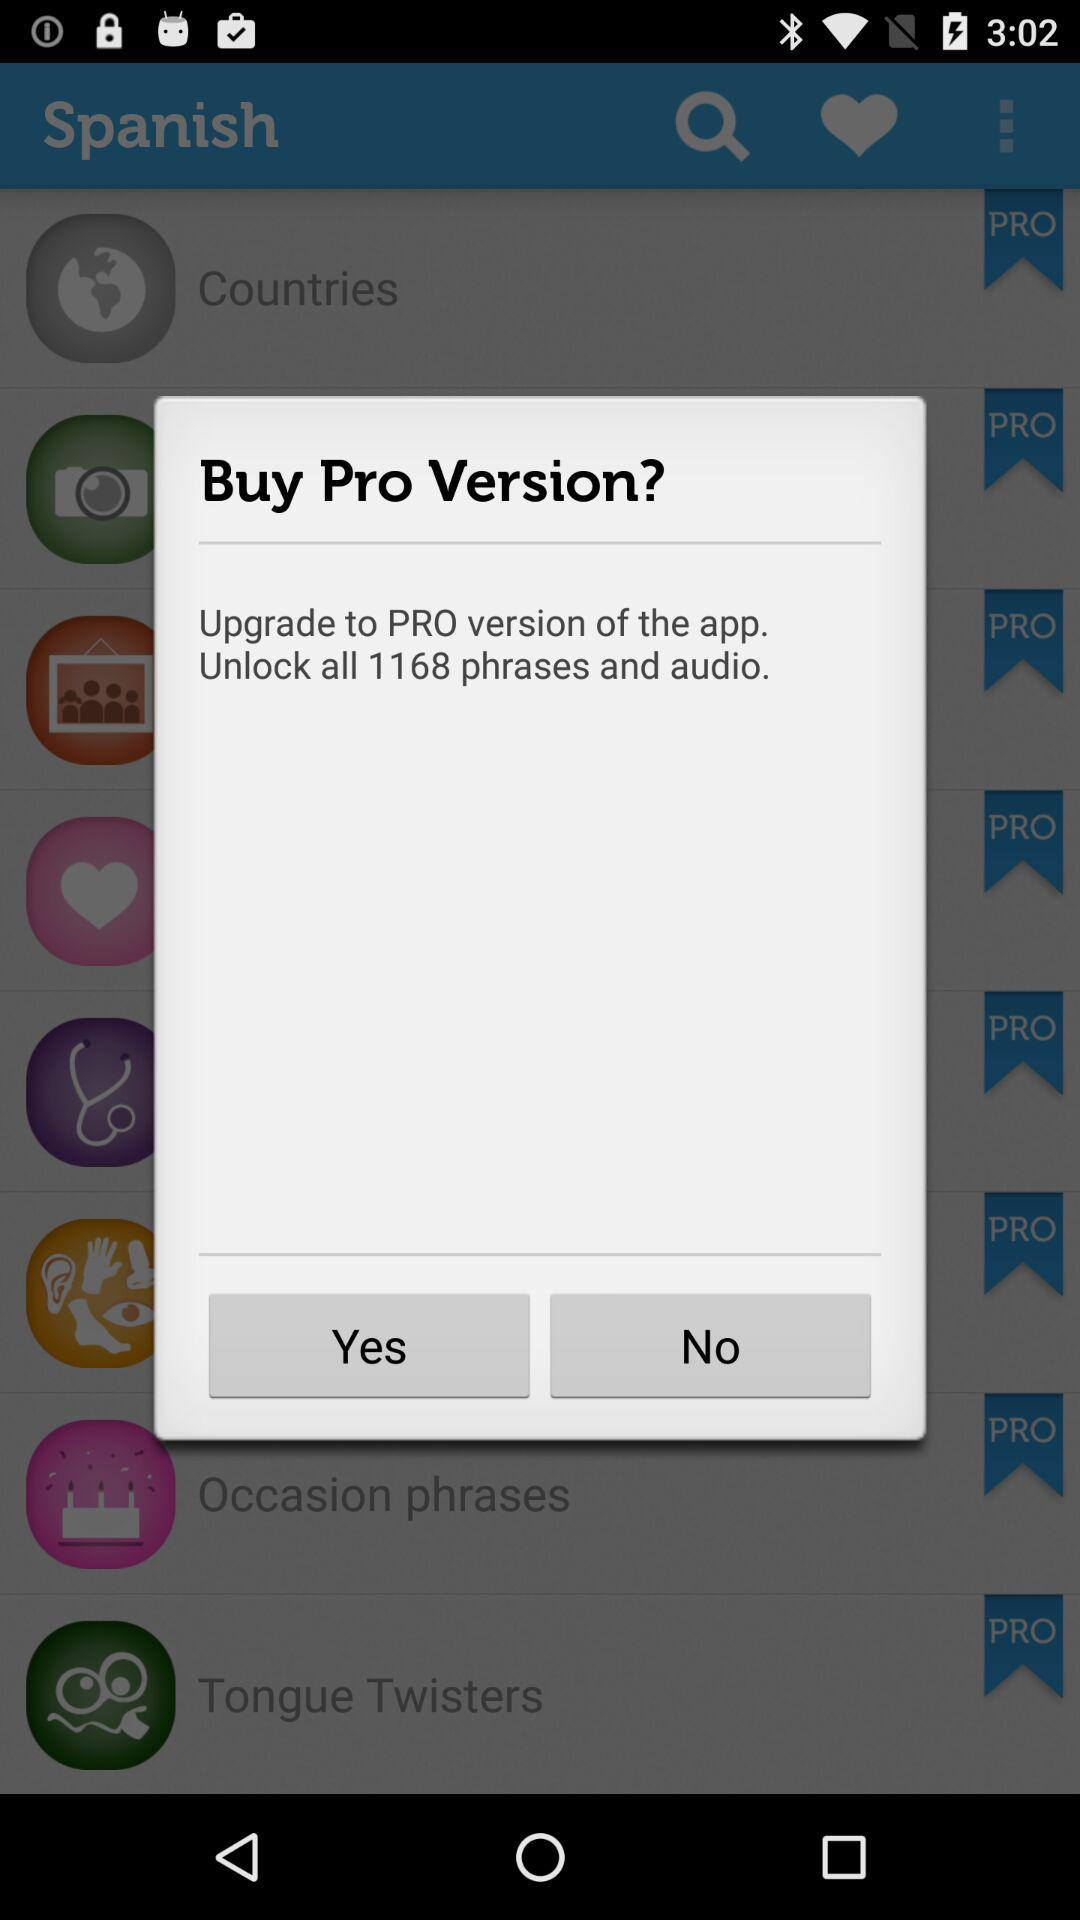How many phrases and audio in total are there? There are 1168 phrases and audio. 